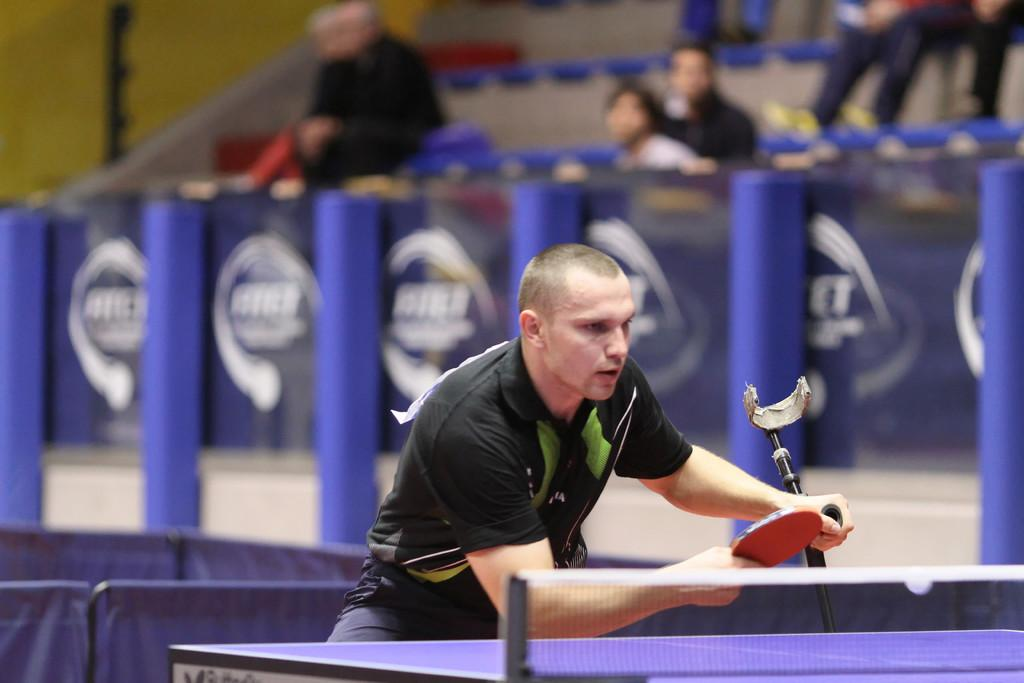Who is present in the image? There is a person in the image. What is the person wearing? The person is wearing a black t-shirt. What is the person holding in the image? The person is holding a table tennis bat. Are there any other people in the image? Yes, there are people watching the person in the image. What type of glue is being used by the person in the image? There is no glue present in the image; the person is holding a table tennis bat. 